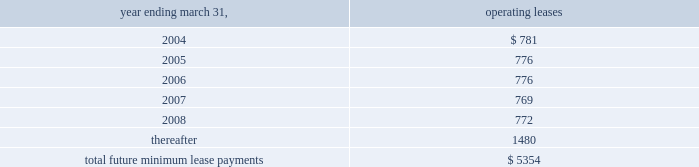A lump sum buyout cost of approximately $ 1.1 million .
Total rent expense under these leases , included in the accompanying consolidated statements of operations , was approximately $ 893000 , $ 856000 and $ 823000 for the fiscal years ended march 31 , 2001 , 2002 and 2003 , respectively .
During the fiscal year ended march 31 , 2000 , the company entered into 36-month operating leases totaling approximately $ 644000 for the lease of office furniture .
These leases ended in fiscal year 2003 and at the company 2019s option the furniture was purchased at its fair market value .
Rental expense recorded for these leases during the fiscal years ended march 31 , 2001 , 2002 and 2003 was approximately $ 215000 , $ 215000 and $ 127000 respectively .
During fiscal 2000 , the company entered into a 36-month capital lease for computer equipment and software for approximately $ 221000 .
This lease ended in fiscal year 2003 and at the company 2019s option these assets were purchased at the stipulated buyout price .
Future minimum lease payments under all non-cancelable operating leases as of march 31 , 2003 are approximately as follows ( in thousands ) : .
From time to time , the company is involved in legal and administrative proceedings and claims of various types .
While any litigation contains an element of uncertainty , management , in consultation with the company 2019s general counsel , presently believes that the outcome of each such other proceedings or claims which are pending or known to be threatened , or all of them combined , will not have a material adverse effect on the company .
Stock option and purchase plans all stock options granted by the company under the below-described plans were granted at the fair value of the underlying common stock at the date of grant .
Outstanding stock options , if not exercised , expire 10 years from the date of grant .
The 1992 combination stock option plan ( the combination plan ) , as amended , was adopted in september 1992 as a combination and restatement of the company 2019s then outstanding incentive stock option plan and nonqualified plan .
A total of 2670859 options were awarded from the combination plan during its ten-year restatement term that ended on may 1 , 2002 .
As of march 31 , 2003 , 1286042 of these options remain outstanding and eligible for future exercise .
These options are held by company employees and generally become exercisable ratably over five years .
The 1998 equity incentive plan , ( the equity incentive plan ) , was adopted by the company in august 1998 .
The equity incentive plan provides for grants of options to key employees , directors , advisors and consultants as either incentive stock options or nonqualified stock options as determined by the company 2019s board of directors .
A maximum of 1000000 shares of common stock may be awarded under this plan .
Options granted under the equity incentive plan are exercisable at such times and subject to such terms as the board of directors may specify at the time of each stock option grant .
Options outstanding under the equity incentive plan have vesting periods of 3 to 5 years from the date of grant .
The 2000 stock incentive plan , ( the 2000 plan ) , was adopted by the company in august 2000 .
The 2000 plan provides for grants of options to key employees , directors , advisors and consultants to the company or its subsidiaries as either incentive or nonqualified stock options as determined by the company 2019s board of directors .
Up to 1400000 shares of common stock may be awarded under the 2000 plan and are exercisable at such times and subject to such terms as the board of directors may specify at the time of each stock option grant .
Options outstanding under the 2000 plan generally vested 4 years from the date of grant .
The company has a nonqualified stock option plan for non-employee directors ( the directors 2019 plan ) .
The directors 2019 plan , as amended , was adopted in july 1989 and provides for grants of options to purchase shares of the company 2019s common stock to non-employee directors of the company .
Up to 400000 shares of common stock may be awarded under the directors 2019 plan .
Options outstanding under the directors 2019 plan have vesting periods of 1 to 5 years from the date of grant .
Notes to consolidated financial statements ( continued ) march 31 , 2003 page 25 .
For the options awarded under the 1992 plan , what is the expected annual exercise of the shares? 
Computations: (2670859 / 5)
Answer: 534171.8. A lump sum buyout cost of approximately $ 1.1 million .
Total rent expense under these leases , included in the accompanying consolidated statements of operations , was approximately $ 893000 , $ 856000 and $ 823000 for the fiscal years ended march 31 , 2001 , 2002 and 2003 , respectively .
During the fiscal year ended march 31 , 2000 , the company entered into 36-month operating leases totaling approximately $ 644000 for the lease of office furniture .
These leases ended in fiscal year 2003 and at the company 2019s option the furniture was purchased at its fair market value .
Rental expense recorded for these leases during the fiscal years ended march 31 , 2001 , 2002 and 2003 was approximately $ 215000 , $ 215000 and $ 127000 respectively .
During fiscal 2000 , the company entered into a 36-month capital lease for computer equipment and software for approximately $ 221000 .
This lease ended in fiscal year 2003 and at the company 2019s option these assets were purchased at the stipulated buyout price .
Future minimum lease payments under all non-cancelable operating leases as of march 31 , 2003 are approximately as follows ( in thousands ) : .
From time to time , the company is involved in legal and administrative proceedings and claims of various types .
While any litigation contains an element of uncertainty , management , in consultation with the company 2019s general counsel , presently believes that the outcome of each such other proceedings or claims which are pending or known to be threatened , or all of them combined , will not have a material adverse effect on the company .
Stock option and purchase plans all stock options granted by the company under the below-described plans were granted at the fair value of the underlying common stock at the date of grant .
Outstanding stock options , if not exercised , expire 10 years from the date of grant .
The 1992 combination stock option plan ( the combination plan ) , as amended , was adopted in september 1992 as a combination and restatement of the company 2019s then outstanding incentive stock option plan and nonqualified plan .
A total of 2670859 options were awarded from the combination plan during its ten-year restatement term that ended on may 1 , 2002 .
As of march 31 , 2003 , 1286042 of these options remain outstanding and eligible for future exercise .
These options are held by company employees and generally become exercisable ratably over five years .
The 1998 equity incentive plan , ( the equity incentive plan ) , was adopted by the company in august 1998 .
The equity incentive plan provides for grants of options to key employees , directors , advisors and consultants as either incentive stock options or nonqualified stock options as determined by the company 2019s board of directors .
A maximum of 1000000 shares of common stock may be awarded under this plan .
Options granted under the equity incentive plan are exercisable at such times and subject to such terms as the board of directors may specify at the time of each stock option grant .
Options outstanding under the equity incentive plan have vesting periods of 3 to 5 years from the date of grant .
The 2000 stock incentive plan , ( the 2000 plan ) , was adopted by the company in august 2000 .
The 2000 plan provides for grants of options to key employees , directors , advisors and consultants to the company or its subsidiaries as either incentive or nonqualified stock options as determined by the company 2019s board of directors .
Up to 1400000 shares of common stock may be awarded under the 2000 plan and are exercisable at such times and subject to such terms as the board of directors may specify at the time of each stock option grant .
Options outstanding under the 2000 plan generally vested 4 years from the date of grant .
The company has a nonqualified stock option plan for non-employee directors ( the directors 2019 plan ) .
The directors 2019 plan , as amended , was adopted in july 1989 and provides for grants of options to purchase shares of the company 2019s common stock to non-employee directors of the company .
Up to 400000 shares of common stock may be awarded under the directors 2019 plan .
Options outstanding under the directors 2019 plan have vesting periods of 1 to 5 years from the date of grant .
Notes to consolidated financial statements ( continued ) march 31 , 2003 page 25 .
Is the vesting under the 2000 employee equity plan potentially longer than under the directors 1989 plan? 
Computations: (4 > 5)
Answer: no. A lump sum buyout cost of approximately $ 1.1 million .
Total rent expense under these leases , included in the accompanying consolidated statements of operations , was approximately $ 893000 , $ 856000 and $ 823000 for the fiscal years ended march 31 , 2001 , 2002 and 2003 , respectively .
During the fiscal year ended march 31 , 2000 , the company entered into 36-month operating leases totaling approximately $ 644000 for the lease of office furniture .
These leases ended in fiscal year 2003 and at the company 2019s option the furniture was purchased at its fair market value .
Rental expense recorded for these leases during the fiscal years ended march 31 , 2001 , 2002 and 2003 was approximately $ 215000 , $ 215000 and $ 127000 respectively .
During fiscal 2000 , the company entered into a 36-month capital lease for computer equipment and software for approximately $ 221000 .
This lease ended in fiscal year 2003 and at the company 2019s option these assets were purchased at the stipulated buyout price .
Future minimum lease payments under all non-cancelable operating leases as of march 31 , 2003 are approximately as follows ( in thousands ) : .
From time to time , the company is involved in legal and administrative proceedings and claims of various types .
While any litigation contains an element of uncertainty , management , in consultation with the company 2019s general counsel , presently believes that the outcome of each such other proceedings or claims which are pending or known to be threatened , or all of them combined , will not have a material adverse effect on the company .
Stock option and purchase plans all stock options granted by the company under the below-described plans were granted at the fair value of the underlying common stock at the date of grant .
Outstanding stock options , if not exercised , expire 10 years from the date of grant .
The 1992 combination stock option plan ( the combination plan ) , as amended , was adopted in september 1992 as a combination and restatement of the company 2019s then outstanding incentive stock option plan and nonqualified plan .
A total of 2670859 options were awarded from the combination plan during its ten-year restatement term that ended on may 1 , 2002 .
As of march 31 , 2003 , 1286042 of these options remain outstanding and eligible for future exercise .
These options are held by company employees and generally become exercisable ratably over five years .
The 1998 equity incentive plan , ( the equity incentive plan ) , was adopted by the company in august 1998 .
The equity incentive plan provides for grants of options to key employees , directors , advisors and consultants as either incentive stock options or nonqualified stock options as determined by the company 2019s board of directors .
A maximum of 1000000 shares of common stock may be awarded under this plan .
Options granted under the equity incentive plan are exercisable at such times and subject to such terms as the board of directors may specify at the time of each stock option grant .
Options outstanding under the equity incentive plan have vesting periods of 3 to 5 years from the date of grant .
The 2000 stock incentive plan , ( the 2000 plan ) , was adopted by the company in august 2000 .
The 2000 plan provides for grants of options to key employees , directors , advisors and consultants to the company or its subsidiaries as either incentive or nonqualified stock options as determined by the company 2019s board of directors .
Up to 1400000 shares of common stock may be awarded under the 2000 plan and are exercisable at such times and subject to such terms as the board of directors may specify at the time of each stock option grant .
Options outstanding under the 2000 plan generally vested 4 years from the date of grant .
The company has a nonqualified stock option plan for non-employee directors ( the directors 2019 plan ) .
The directors 2019 plan , as amended , was adopted in july 1989 and provides for grants of options to purchase shares of the company 2019s common stock to non-employee directors of the company .
Up to 400000 shares of common stock may be awarded under the directors 2019 plan .
Options outstanding under the directors 2019 plan have vesting periods of 1 to 5 years from the date of grant .
Notes to consolidated financial statements ( continued ) march 31 , 2003 page 25 .
What portion of total future minimum lease payments is due in the next 24 months? 
Computations: ((781 + 776) / 5354)
Answer: 0.29081. 